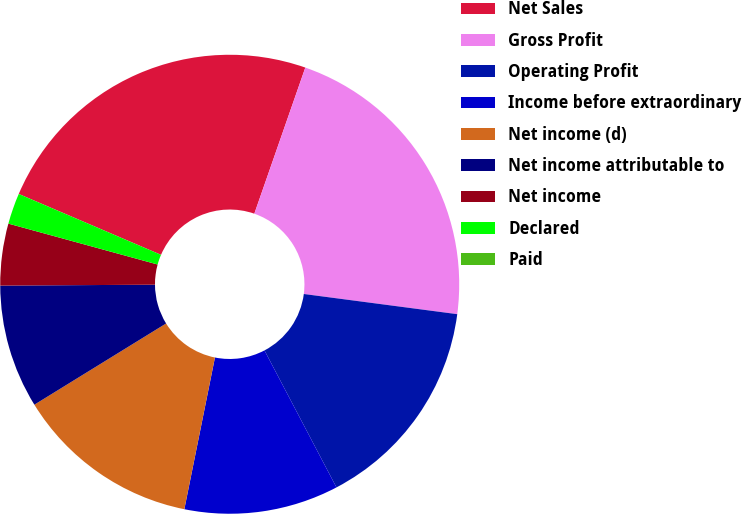Convert chart. <chart><loc_0><loc_0><loc_500><loc_500><pie_chart><fcel>Net Sales<fcel>Gross Profit<fcel>Operating Profit<fcel>Income before extraordinary<fcel>Net income (d)<fcel>Net income attributable to<fcel>Net income<fcel>Declared<fcel>Paid<nl><fcel>23.91%<fcel>21.74%<fcel>15.22%<fcel>10.87%<fcel>13.04%<fcel>8.7%<fcel>4.35%<fcel>2.18%<fcel>0.0%<nl></chart> 